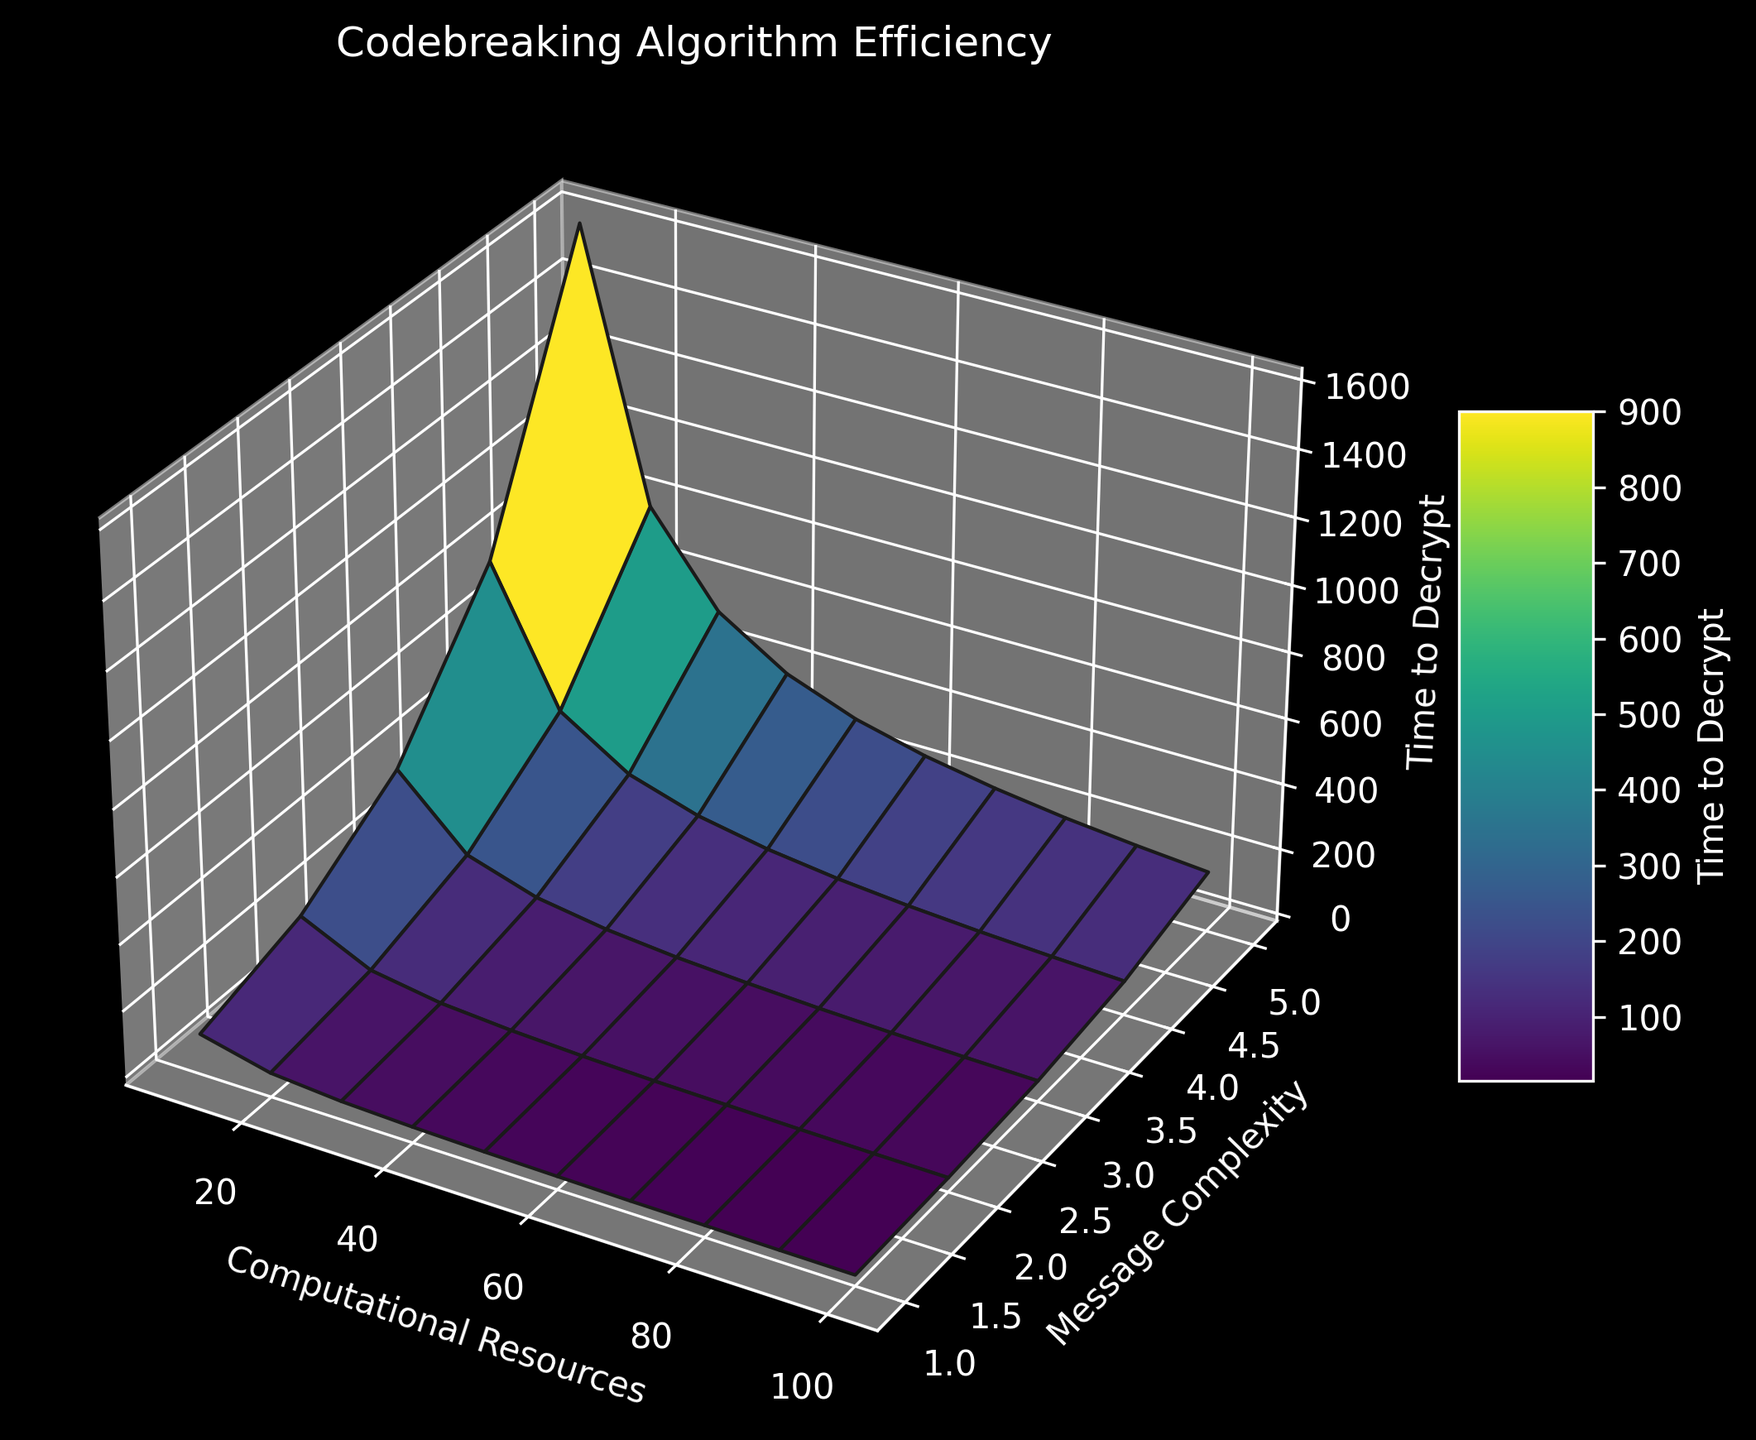What computational resources and message complexity combination results in the minimum time to decrypt? Check the lowest point on the surface plot, represented by the smallest Z value. The minimum time to decrypt is 10, which correlates with 100 computational resources and message complexity of 1.
Answer: 100 computational resources, 1 message complexity How does the time to decrypt change as computational resources increase from 10 to 100 for a fixed message complexity of 3? Identify the Z values along the line where the message complexity is 3. As computational resources increase from 10 to 100, the time to decrypt decreases from 400 to 40.
Answer: Decreases from 400 to 40 What's the rate of change in decryption time for increasing message complexity from 1 to 5, given 60 computational resources? Identify the time to decrypt values for message complexity from 1 to 5 (17, 33, 67, 133, 267). Calculate the differences: 33-17=16, 67-33=34, 133-67=66, and 267-133=134.
Answer: 16, 34, 66, 134 Is there a visible trend in the distribution of decryption times as message complexity increases? Visual inspection shows that the surface plot rises steeply as the message complexity increases for each level of computational resources.
Answer: Decryption times increase significantly with higher message complexity Compare the time to decrypt for message complexity of 4 between 30 and 90 computational resources. Find Z values where message complexity is 4. For 30 resources, it's 266; for 90 resources, it's 89. 266 is much larger than 89.
Answer: 266 vs. 89 What color on the surface plot represents the highest decryption times? Inspect the color gradient on the surface plot. The highest decryption times are represented by colors at the green end of the viridis colormap.
Answer: Green What is the shape of the decryption time curve as computational resources are doubled, keeping message complexity constant at 2? Observe the curve's shape along the line where message complexity is 2. The decryption time decreases exponentially from 200 to 20 as computational resources double from 10 to 100.
Answer: Exponential decrease When message complexity is kept constant at 4, how does the time to decrypt compare between 40 and 70 computational resources? For message complexity 4, the time to decrypt is 200 (40 resources) and 114 (70 resources). 200 is significantly higher than 114.
Answer: 200 (40 resources), 114 (70 resources) 